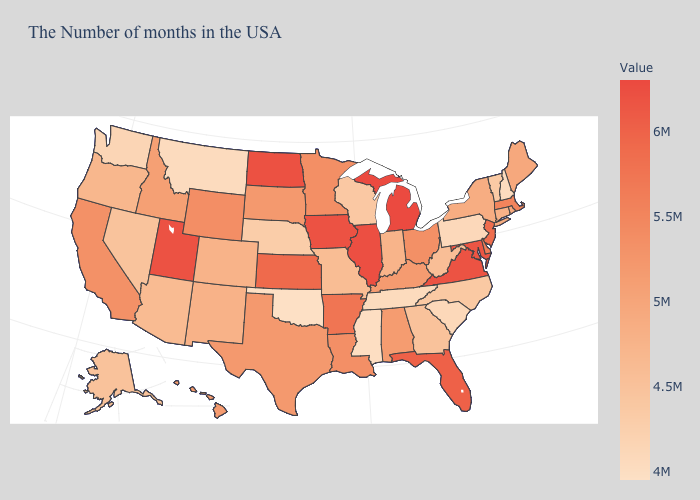Among the states that border Wisconsin , does Michigan have the highest value?
Write a very short answer. Yes. Among the states that border Colorado , does Utah have the highest value?
Be succinct. Yes. Does Oklahoma have the lowest value in the USA?
Write a very short answer. Yes. Which states have the lowest value in the West?
Write a very short answer. Montana. Among the states that border Michigan , which have the lowest value?
Be succinct. Wisconsin. Does Maryland have the lowest value in the USA?
Keep it brief. No. Among the states that border Utah , which have the highest value?
Give a very brief answer. Wyoming. Does New Hampshire have the lowest value in the Northeast?
Be succinct. Yes. Which states have the highest value in the USA?
Be succinct. Michigan. 